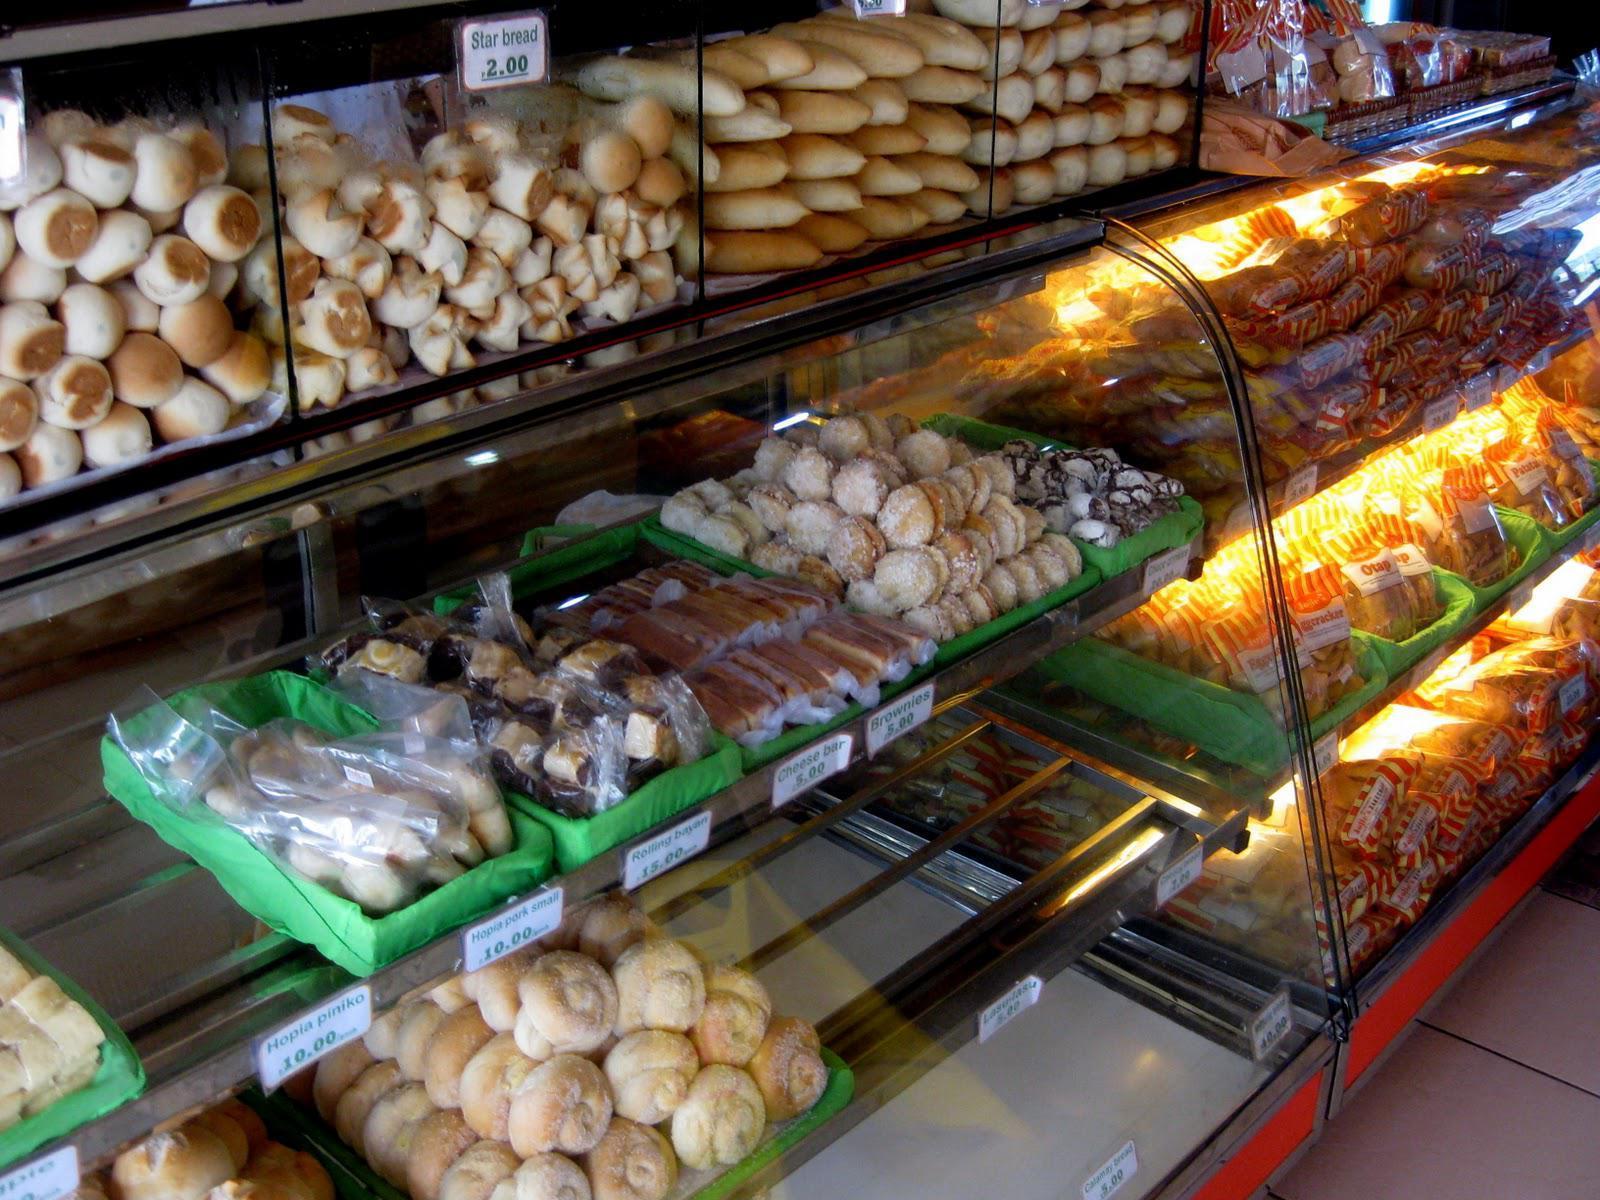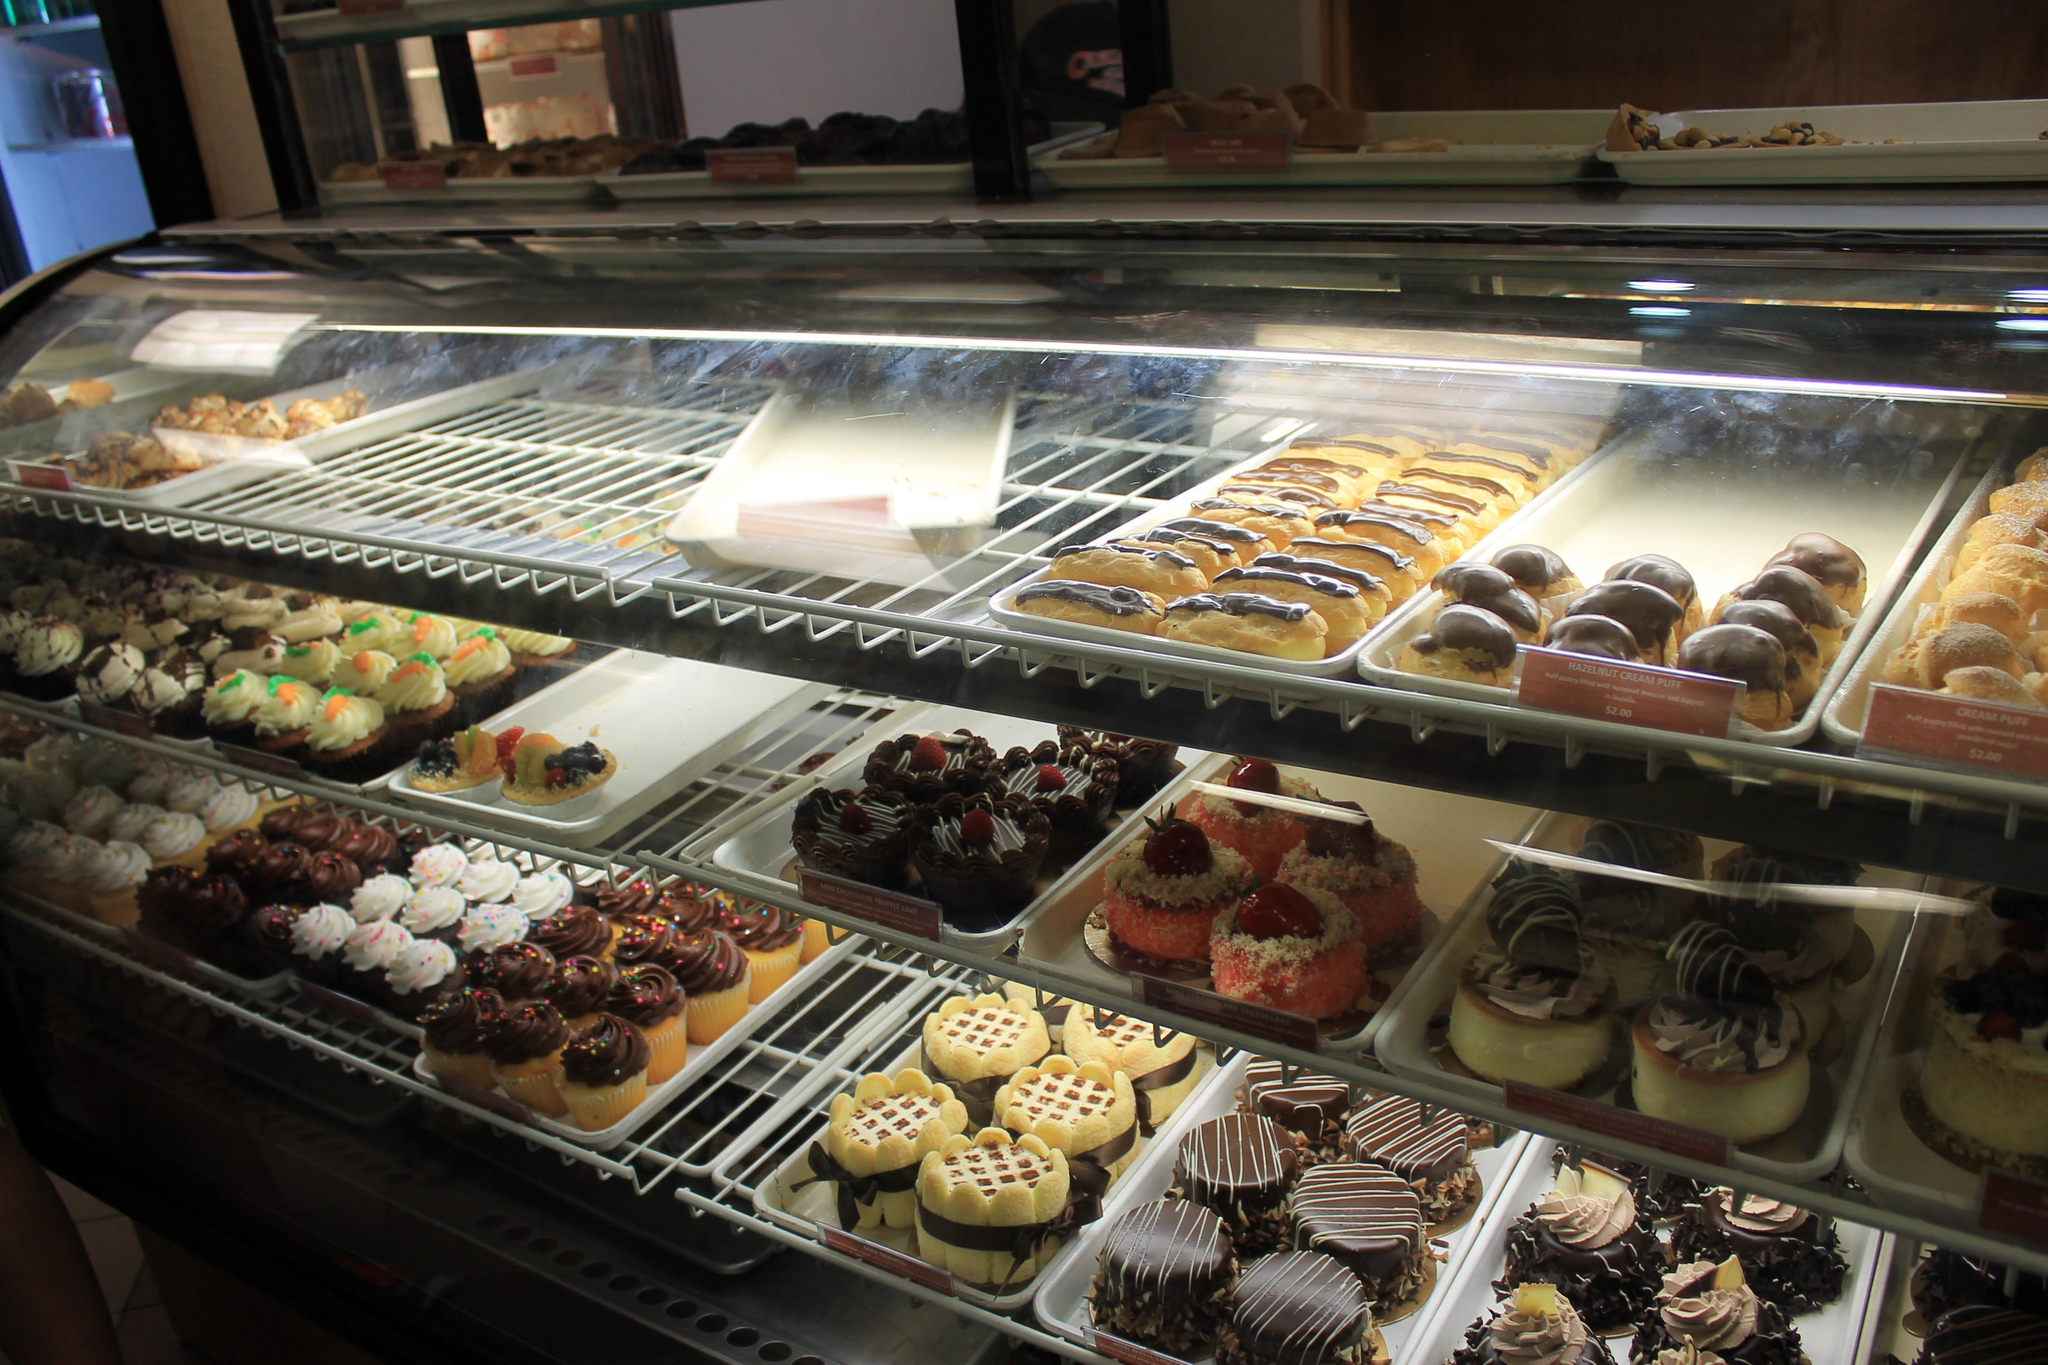The first image is the image on the left, the second image is the image on the right. Examine the images to the left and right. Is the description "There are at least 4 full size cakes in one of the images." accurate? Answer yes or no. No. 